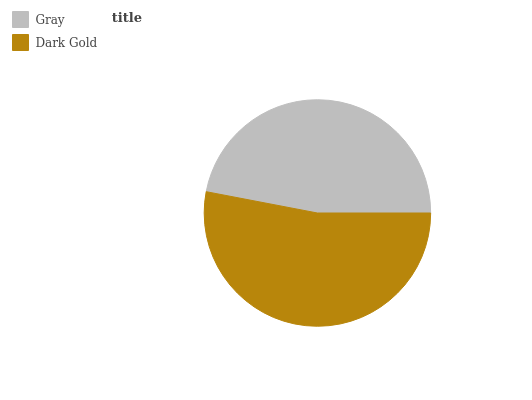Is Gray the minimum?
Answer yes or no. Yes. Is Dark Gold the maximum?
Answer yes or no. Yes. Is Dark Gold the minimum?
Answer yes or no. No. Is Dark Gold greater than Gray?
Answer yes or no. Yes. Is Gray less than Dark Gold?
Answer yes or no. Yes. Is Gray greater than Dark Gold?
Answer yes or no. No. Is Dark Gold less than Gray?
Answer yes or no. No. Is Dark Gold the high median?
Answer yes or no. Yes. Is Gray the low median?
Answer yes or no. Yes. Is Gray the high median?
Answer yes or no. No. Is Dark Gold the low median?
Answer yes or no. No. 